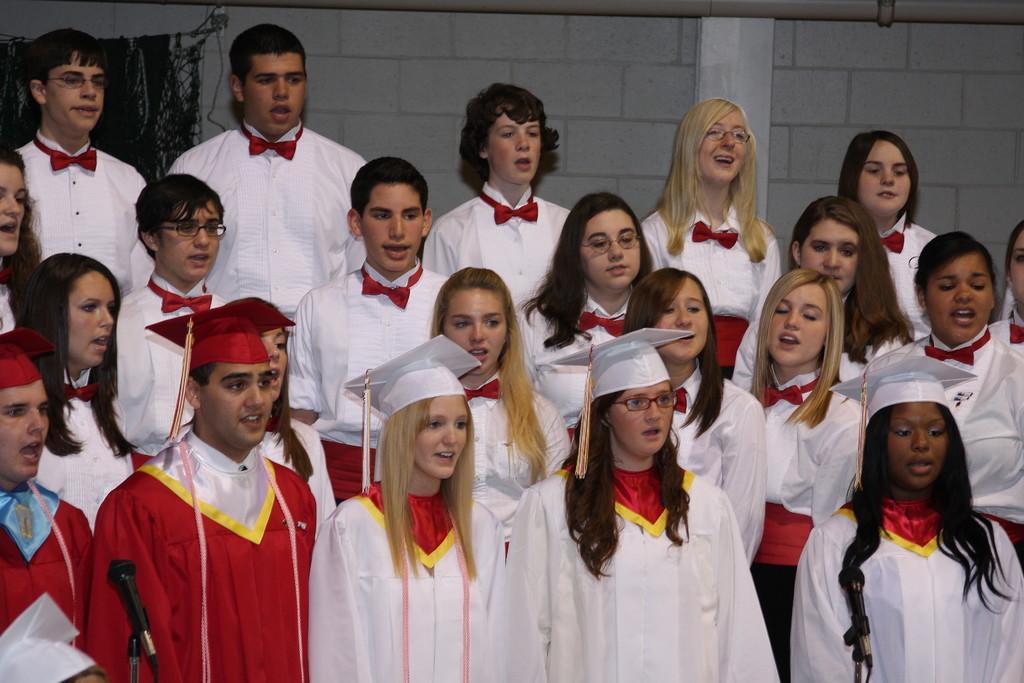Can you describe this image briefly? In this image I can see group of people standing. There is a microphone with stand and in the background there is a wall. 